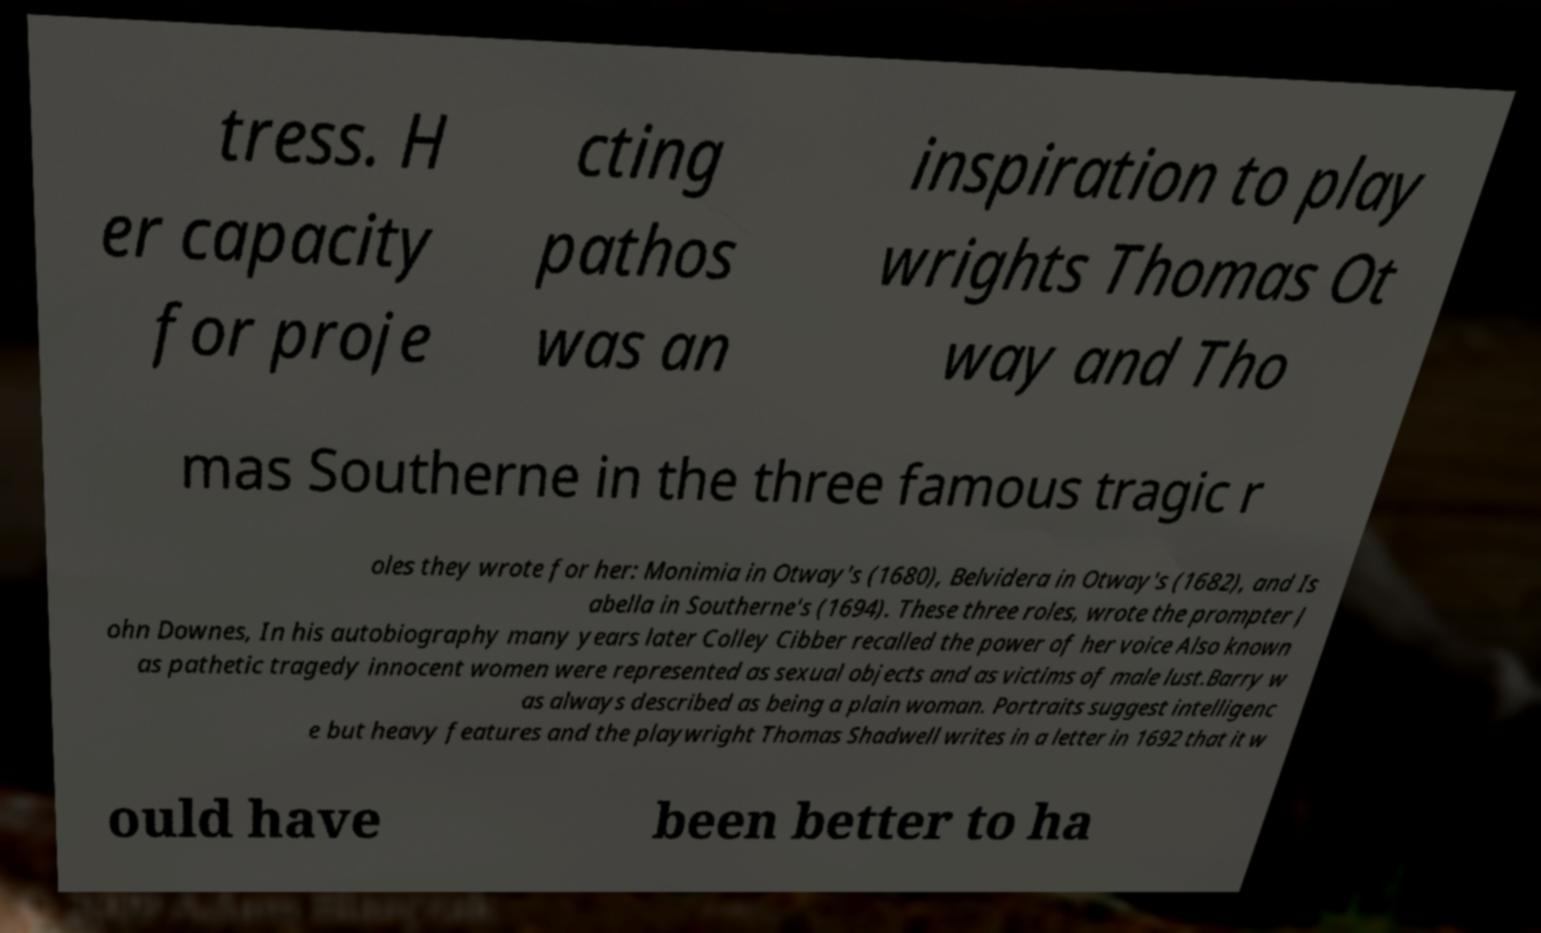Can you accurately transcribe the text from the provided image for me? tress. H er capacity for proje cting pathos was an inspiration to play wrights Thomas Ot way and Tho mas Southerne in the three famous tragic r oles they wrote for her: Monimia in Otway's (1680), Belvidera in Otway's (1682), and Is abella in Southerne's (1694). These three roles, wrote the prompter J ohn Downes, In his autobiography many years later Colley Cibber recalled the power of her voice Also known as pathetic tragedy innocent women were represented as sexual objects and as victims of male lust.Barry w as always described as being a plain woman. Portraits suggest intelligenc e but heavy features and the playwright Thomas Shadwell writes in a letter in 1692 that it w ould have been better to ha 